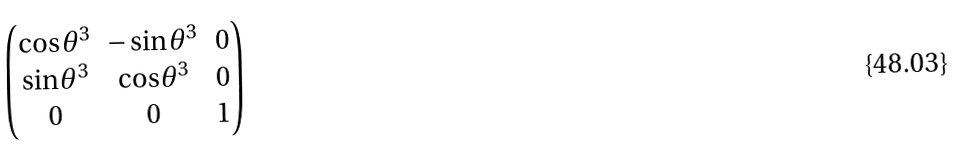Convert formula to latex. <formula><loc_0><loc_0><loc_500><loc_500>\begin{pmatrix} \cos \theta ^ { 3 } & - \sin \theta ^ { 3 } & 0 \\ \sin \theta ^ { 3 } & \cos \theta ^ { 3 } & 0 \\ 0 & 0 & 1 \end{pmatrix}</formula> 